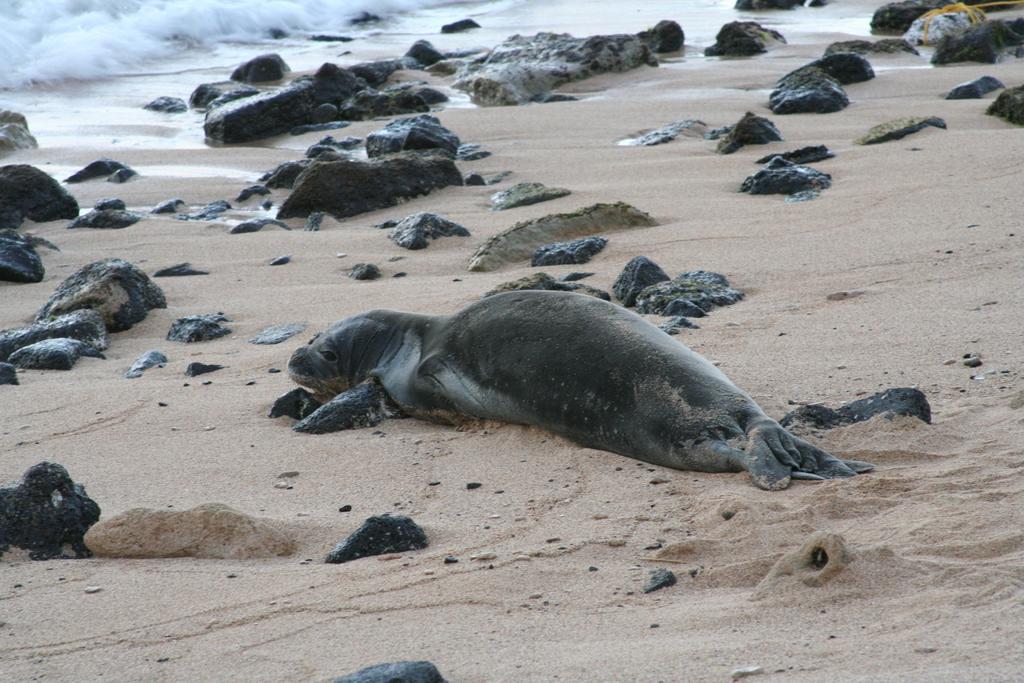Please provide a concise description of this image. This picture is clicked at the seashore. At the bottom of the picture, we see sand, stones and a seal in black color. In the background, we see water and this water might be in the sea. 